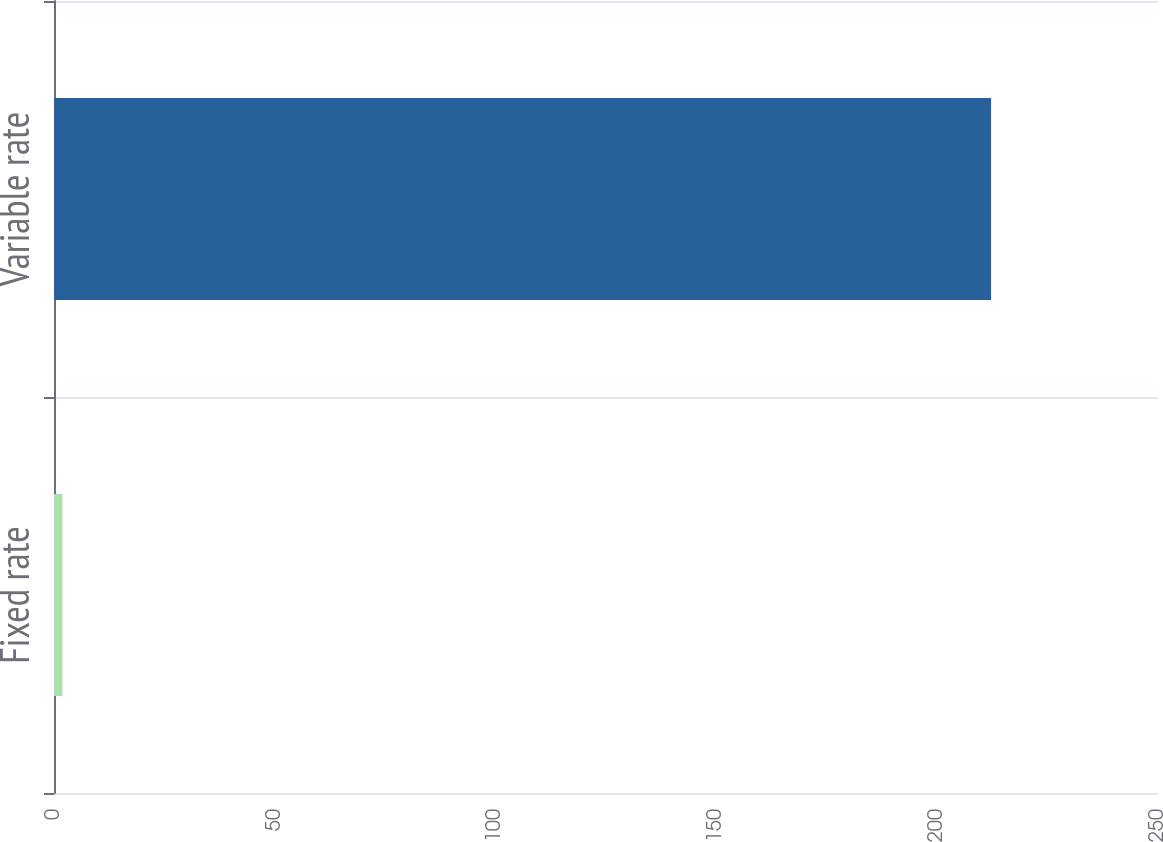<chart> <loc_0><loc_0><loc_500><loc_500><bar_chart><fcel>Fixed rate<fcel>Variable rate<nl><fcel>1.9<fcel>212.2<nl></chart> 